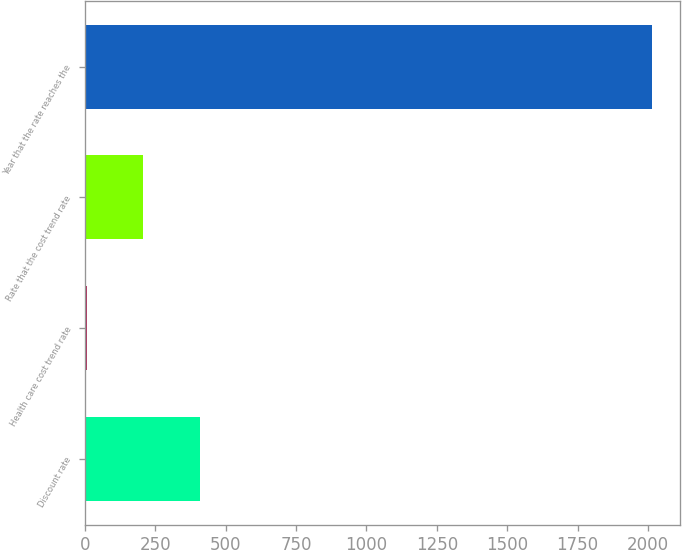Convert chart to OTSL. <chart><loc_0><loc_0><loc_500><loc_500><bar_chart><fcel>Discount rate<fcel>Health care cost trend rate<fcel>Rate that the cost trend rate<fcel>Year that the rate reaches the<nl><fcel>408.34<fcel>7.18<fcel>207.76<fcel>2013<nl></chart> 